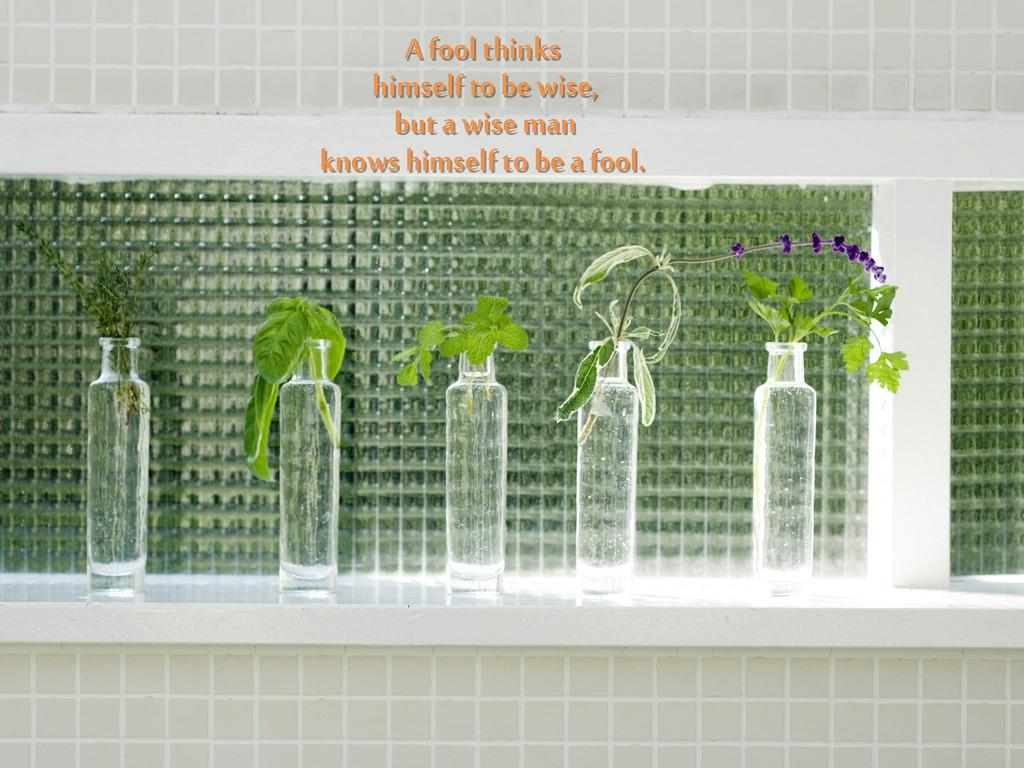How many bottles are visible in the image? There are five bottles in the image. What is inside each of the bottles? There are five plants in the bottles. Where are the bottles and plants located? The bottles and plants are placed on a table. What color is the wall in the background? The wall in the background is green in color. Are there any dinosaurs visible in the image? No, there are no dinosaurs present in the image. 